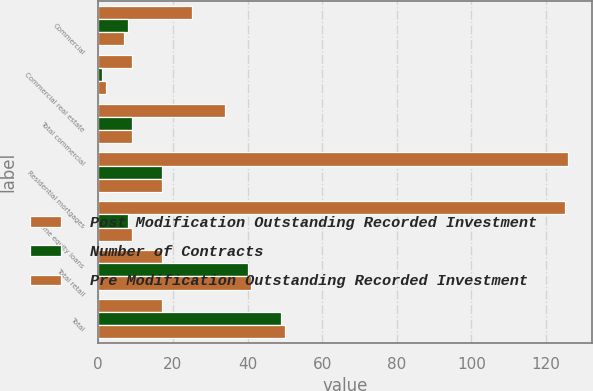<chart> <loc_0><loc_0><loc_500><loc_500><stacked_bar_chart><ecel><fcel>Commercial<fcel>Commercial real estate<fcel>Total commercial<fcel>Residential mortgages<fcel>Home equity loans<fcel>Total retail<fcel>Total<nl><fcel>Post Modification Outstanding Recorded Investment<fcel>25<fcel>9<fcel>34<fcel>126<fcel>125<fcel>17<fcel>17<nl><fcel>Number of Contracts<fcel>8<fcel>1<fcel>9<fcel>17<fcel>8<fcel>40<fcel>49<nl><fcel>Pre Modification Outstanding Recorded Investment<fcel>7<fcel>2<fcel>9<fcel>17<fcel>9<fcel>41<fcel>50<nl></chart> 